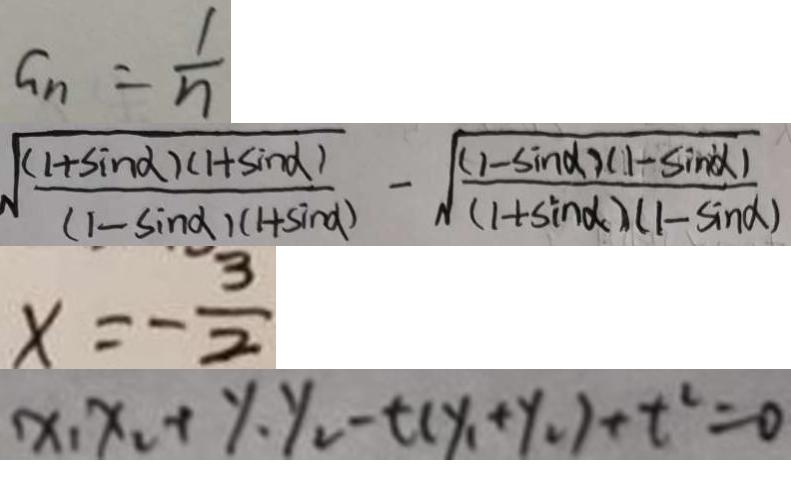Convert formula to latex. <formula><loc_0><loc_0><loc_500><loc_500>G _ { n } = \frac { 1 } { n } 
 \sqrt { \frac { ( 1 + \sin \alpha ) ( 1 + \sin \alpha ) ) } { ( 1 - \sin \alpha ) ( 1 + \sin \alpha ) } } - \sqrt { \frac { ( 1 - \sin \alpha ) ( 1 - \sin \alpha ) ) } { ( 1 + \sin \alpha ) ( 1 - \sin \alpha ) } } 
 x = - \frac { 3 } { 2 } 
 x _ { 1 } x _ { 2 } + y _ { 1 } y _ { 2 } - t ( y _ { 1 } + y _ { 2 } ) + t ^ { 2 } = 0</formula> 